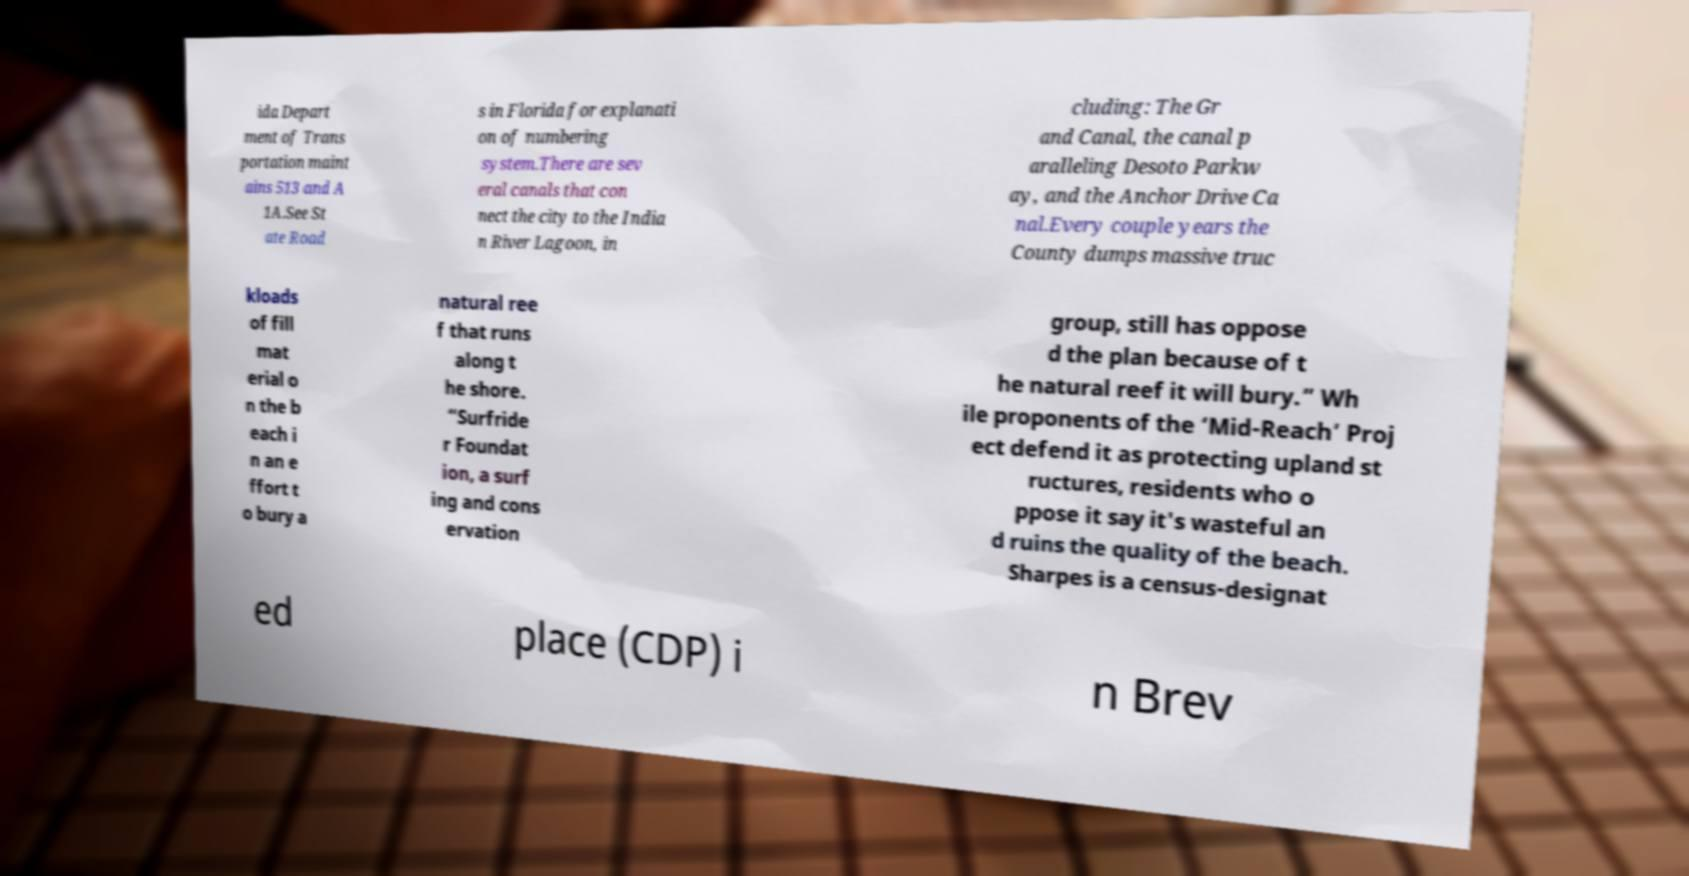There's text embedded in this image that I need extracted. Can you transcribe it verbatim? ida Depart ment of Trans portation maint ains 513 and A 1A.See St ate Road s in Florida for explanati on of numbering system.There are sev eral canals that con nect the city to the India n River Lagoon, in cluding: The Gr and Canal, the canal p aralleling Desoto Parkw ay, and the Anchor Drive Ca nal.Every couple years the County dumps massive truc kloads of fill mat erial o n the b each i n an e ffort t o bury a natural ree f that runs along t he shore. “Surfride r Foundat ion, a surf ing and cons ervation group, still has oppose d the plan because of t he natural reef it will bury.” Wh ile proponents of the ‘Mid-Reach’ Proj ect defend it as protecting upland st ructures, residents who o ppose it say it's wasteful an d ruins the quality of the beach. Sharpes is a census-designat ed place (CDP) i n Brev 